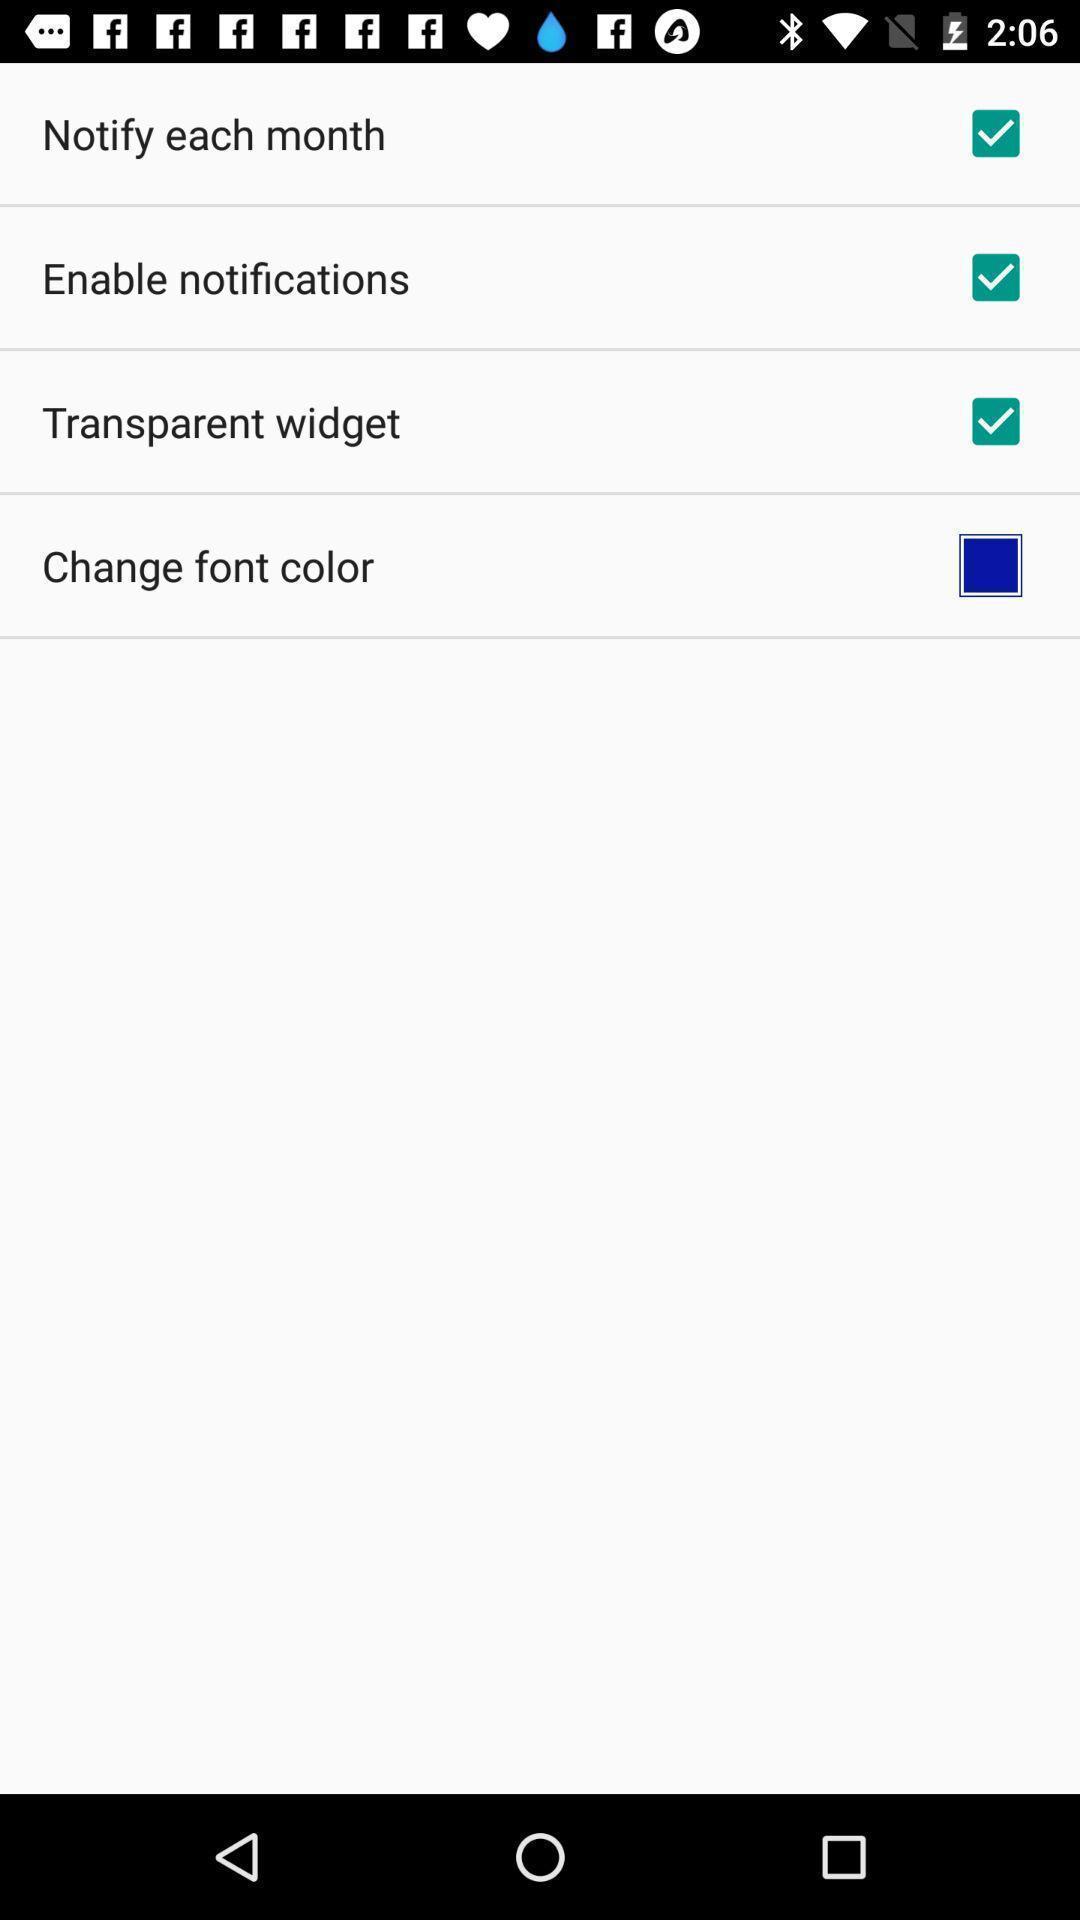Describe the visual elements of this screenshot. Page showing various options to choose for couples app. 